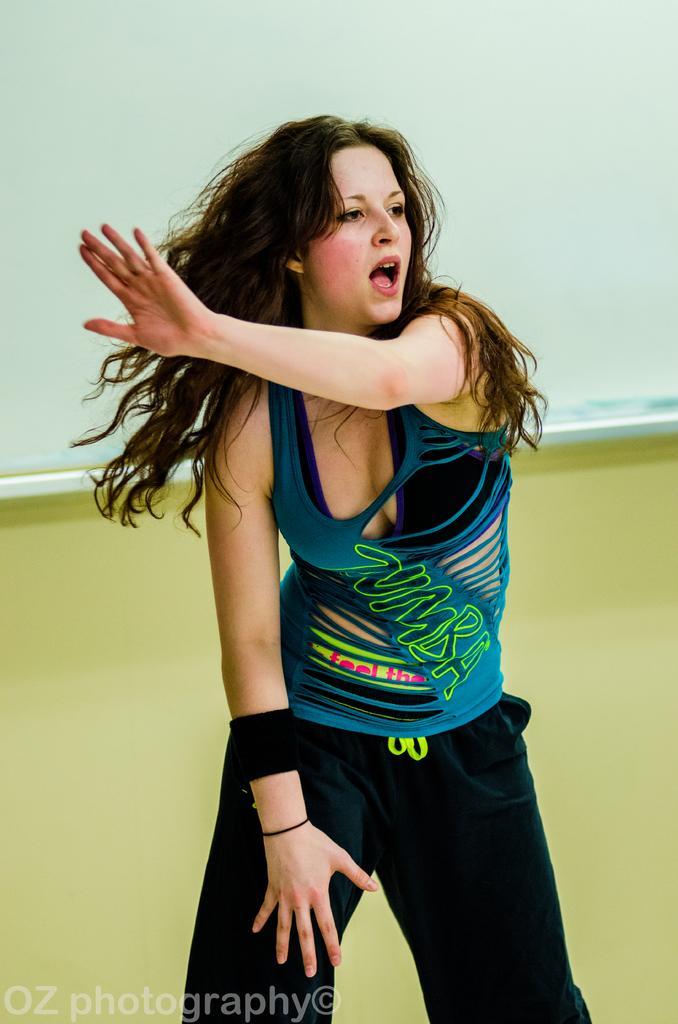Could you give a brief overview of what you see in this image? In this image we can see a woman wearing a dress is standing on the floor. In the bottom we can see some text. In the background, we can see a wall. 